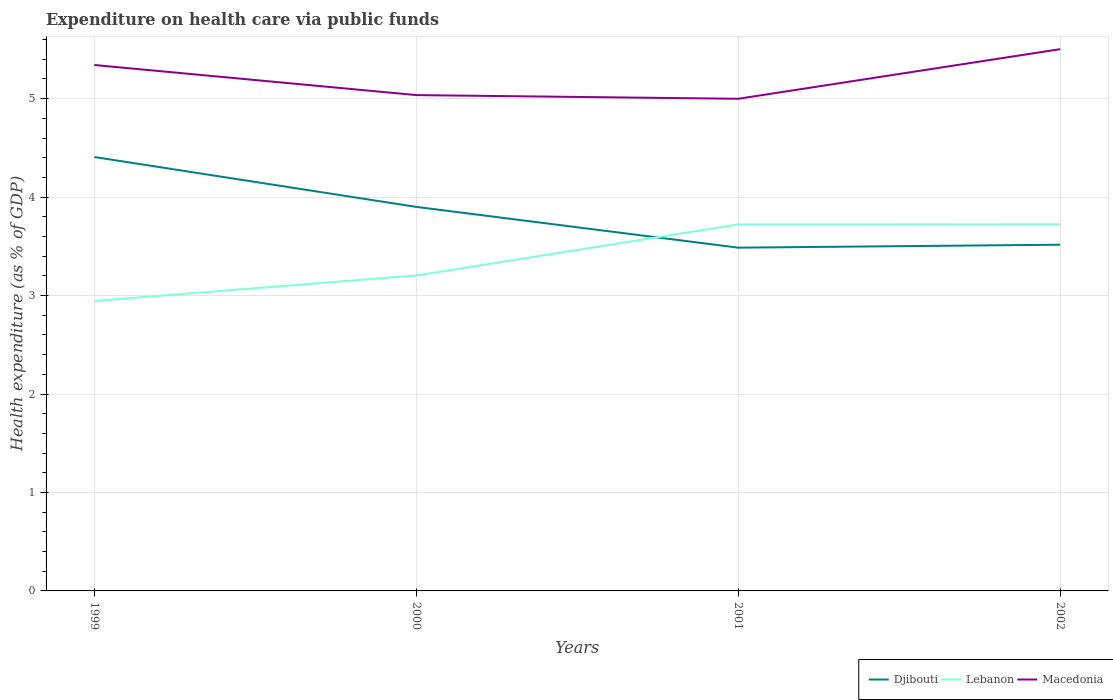How many different coloured lines are there?
Provide a succinct answer. 3. Does the line corresponding to Macedonia intersect with the line corresponding to Djibouti?
Your answer should be compact. No. Is the number of lines equal to the number of legend labels?
Offer a terse response. Yes. Across all years, what is the maximum expenditure made on health care in Macedonia?
Your answer should be very brief. 5. What is the total expenditure made on health care in Macedonia in the graph?
Provide a succinct answer. -0.16. What is the difference between the highest and the second highest expenditure made on health care in Macedonia?
Offer a terse response. 0.5. What is the difference between the highest and the lowest expenditure made on health care in Macedonia?
Your answer should be compact. 2. Is the expenditure made on health care in Lebanon strictly greater than the expenditure made on health care in Djibouti over the years?
Ensure brevity in your answer.  No. How many lines are there?
Make the answer very short. 3. How many years are there in the graph?
Your answer should be very brief. 4. What is the difference between two consecutive major ticks on the Y-axis?
Your answer should be compact. 1. Does the graph contain any zero values?
Offer a terse response. No. How many legend labels are there?
Offer a terse response. 3. What is the title of the graph?
Offer a terse response. Expenditure on health care via public funds. What is the label or title of the X-axis?
Your answer should be very brief. Years. What is the label or title of the Y-axis?
Provide a short and direct response. Health expenditure (as % of GDP). What is the Health expenditure (as % of GDP) in Djibouti in 1999?
Provide a succinct answer. 4.41. What is the Health expenditure (as % of GDP) in Lebanon in 1999?
Make the answer very short. 2.95. What is the Health expenditure (as % of GDP) of Macedonia in 1999?
Make the answer very short. 5.34. What is the Health expenditure (as % of GDP) of Djibouti in 2000?
Offer a very short reply. 3.9. What is the Health expenditure (as % of GDP) in Lebanon in 2000?
Your answer should be compact. 3.2. What is the Health expenditure (as % of GDP) of Macedonia in 2000?
Your response must be concise. 5.04. What is the Health expenditure (as % of GDP) of Djibouti in 2001?
Make the answer very short. 3.49. What is the Health expenditure (as % of GDP) in Lebanon in 2001?
Your response must be concise. 3.72. What is the Health expenditure (as % of GDP) of Macedonia in 2001?
Make the answer very short. 5. What is the Health expenditure (as % of GDP) in Djibouti in 2002?
Offer a very short reply. 3.52. What is the Health expenditure (as % of GDP) in Lebanon in 2002?
Provide a short and direct response. 3.72. What is the Health expenditure (as % of GDP) of Macedonia in 2002?
Provide a succinct answer. 5.5. Across all years, what is the maximum Health expenditure (as % of GDP) of Djibouti?
Make the answer very short. 4.41. Across all years, what is the maximum Health expenditure (as % of GDP) in Lebanon?
Make the answer very short. 3.72. Across all years, what is the maximum Health expenditure (as % of GDP) in Macedonia?
Your answer should be compact. 5.5. Across all years, what is the minimum Health expenditure (as % of GDP) in Djibouti?
Offer a terse response. 3.49. Across all years, what is the minimum Health expenditure (as % of GDP) in Lebanon?
Keep it short and to the point. 2.95. Across all years, what is the minimum Health expenditure (as % of GDP) of Macedonia?
Provide a succinct answer. 5. What is the total Health expenditure (as % of GDP) in Djibouti in the graph?
Keep it short and to the point. 15.31. What is the total Health expenditure (as % of GDP) of Lebanon in the graph?
Your answer should be very brief. 13.6. What is the total Health expenditure (as % of GDP) of Macedonia in the graph?
Keep it short and to the point. 20.88. What is the difference between the Health expenditure (as % of GDP) in Djibouti in 1999 and that in 2000?
Your answer should be very brief. 0.51. What is the difference between the Health expenditure (as % of GDP) in Lebanon in 1999 and that in 2000?
Offer a very short reply. -0.26. What is the difference between the Health expenditure (as % of GDP) of Macedonia in 1999 and that in 2000?
Offer a terse response. 0.31. What is the difference between the Health expenditure (as % of GDP) of Djibouti in 1999 and that in 2001?
Ensure brevity in your answer.  0.92. What is the difference between the Health expenditure (as % of GDP) of Lebanon in 1999 and that in 2001?
Provide a succinct answer. -0.78. What is the difference between the Health expenditure (as % of GDP) in Macedonia in 1999 and that in 2001?
Provide a succinct answer. 0.34. What is the difference between the Health expenditure (as % of GDP) of Djibouti in 1999 and that in 2002?
Provide a short and direct response. 0.89. What is the difference between the Health expenditure (as % of GDP) in Lebanon in 1999 and that in 2002?
Provide a succinct answer. -0.78. What is the difference between the Health expenditure (as % of GDP) in Macedonia in 1999 and that in 2002?
Provide a short and direct response. -0.16. What is the difference between the Health expenditure (as % of GDP) in Djibouti in 2000 and that in 2001?
Keep it short and to the point. 0.41. What is the difference between the Health expenditure (as % of GDP) of Lebanon in 2000 and that in 2001?
Provide a short and direct response. -0.52. What is the difference between the Health expenditure (as % of GDP) in Macedonia in 2000 and that in 2001?
Ensure brevity in your answer.  0.04. What is the difference between the Health expenditure (as % of GDP) of Djibouti in 2000 and that in 2002?
Make the answer very short. 0.38. What is the difference between the Health expenditure (as % of GDP) of Lebanon in 2000 and that in 2002?
Ensure brevity in your answer.  -0.52. What is the difference between the Health expenditure (as % of GDP) in Macedonia in 2000 and that in 2002?
Provide a succinct answer. -0.47. What is the difference between the Health expenditure (as % of GDP) in Djibouti in 2001 and that in 2002?
Your response must be concise. -0.03. What is the difference between the Health expenditure (as % of GDP) of Lebanon in 2001 and that in 2002?
Offer a terse response. -0. What is the difference between the Health expenditure (as % of GDP) of Macedonia in 2001 and that in 2002?
Provide a short and direct response. -0.5. What is the difference between the Health expenditure (as % of GDP) of Djibouti in 1999 and the Health expenditure (as % of GDP) of Lebanon in 2000?
Ensure brevity in your answer.  1.2. What is the difference between the Health expenditure (as % of GDP) of Djibouti in 1999 and the Health expenditure (as % of GDP) of Macedonia in 2000?
Keep it short and to the point. -0.63. What is the difference between the Health expenditure (as % of GDP) of Lebanon in 1999 and the Health expenditure (as % of GDP) of Macedonia in 2000?
Ensure brevity in your answer.  -2.09. What is the difference between the Health expenditure (as % of GDP) of Djibouti in 1999 and the Health expenditure (as % of GDP) of Lebanon in 2001?
Provide a short and direct response. 0.68. What is the difference between the Health expenditure (as % of GDP) of Djibouti in 1999 and the Health expenditure (as % of GDP) of Macedonia in 2001?
Your answer should be very brief. -0.59. What is the difference between the Health expenditure (as % of GDP) of Lebanon in 1999 and the Health expenditure (as % of GDP) of Macedonia in 2001?
Offer a very short reply. -2.05. What is the difference between the Health expenditure (as % of GDP) of Djibouti in 1999 and the Health expenditure (as % of GDP) of Lebanon in 2002?
Keep it short and to the point. 0.68. What is the difference between the Health expenditure (as % of GDP) in Djibouti in 1999 and the Health expenditure (as % of GDP) in Macedonia in 2002?
Provide a succinct answer. -1.1. What is the difference between the Health expenditure (as % of GDP) of Lebanon in 1999 and the Health expenditure (as % of GDP) of Macedonia in 2002?
Ensure brevity in your answer.  -2.56. What is the difference between the Health expenditure (as % of GDP) of Djibouti in 2000 and the Health expenditure (as % of GDP) of Lebanon in 2001?
Give a very brief answer. 0.18. What is the difference between the Health expenditure (as % of GDP) in Djibouti in 2000 and the Health expenditure (as % of GDP) in Macedonia in 2001?
Offer a terse response. -1.1. What is the difference between the Health expenditure (as % of GDP) of Lebanon in 2000 and the Health expenditure (as % of GDP) of Macedonia in 2001?
Your answer should be compact. -1.79. What is the difference between the Health expenditure (as % of GDP) in Djibouti in 2000 and the Health expenditure (as % of GDP) in Lebanon in 2002?
Make the answer very short. 0.18. What is the difference between the Health expenditure (as % of GDP) of Djibouti in 2000 and the Health expenditure (as % of GDP) of Macedonia in 2002?
Your response must be concise. -1.6. What is the difference between the Health expenditure (as % of GDP) in Lebanon in 2000 and the Health expenditure (as % of GDP) in Macedonia in 2002?
Offer a terse response. -2.3. What is the difference between the Health expenditure (as % of GDP) in Djibouti in 2001 and the Health expenditure (as % of GDP) in Lebanon in 2002?
Your response must be concise. -0.24. What is the difference between the Health expenditure (as % of GDP) in Djibouti in 2001 and the Health expenditure (as % of GDP) in Macedonia in 2002?
Your response must be concise. -2.02. What is the difference between the Health expenditure (as % of GDP) in Lebanon in 2001 and the Health expenditure (as % of GDP) in Macedonia in 2002?
Offer a terse response. -1.78. What is the average Health expenditure (as % of GDP) of Djibouti per year?
Make the answer very short. 3.83. What is the average Health expenditure (as % of GDP) in Lebanon per year?
Offer a very short reply. 3.4. What is the average Health expenditure (as % of GDP) in Macedonia per year?
Provide a short and direct response. 5.22. In the year 1999, what is the difference between the Health expenditure (as % of GDP) of Djibouti and Health expenditure (as % of GDP) of Lebanon?
Keep it short and to the point. 1.46. In the year 1999, what is the difference between the Health expenditure (as % of GDP) in Djibouti and Health expenditure (as % of GDP) in Macedonia?
Provide a succinct answer. -0.93. In the year 1999, what is the difference between the Health expenditure (as % of GDP) in Lebanon and Health expenditure (as % of GDP) in Macedonia?
Provide a succinct answer. -2.4. In the year 2000, what is the difference between the Health expenditure (as % of GDP) in Djibouti and Health expenditure (as % of GDP) in Lebanon?
Offer a very short reply. 0.7. In the year 2000, what is the difference between the Health expenditure (as % of GDP) of Djibouti and Health expenditure (as % of GDP) of Macedonia?
Your answer should be compact. -1.14. In the year 2000, what is the difference between the Health expenditure (as % of GDP) of Lebanon and Health expenditure (as % of GDP) of Macedonia?
Offer a very short reply. -1.83. In the year 2001, what is the difference between the Health expenditure (as % of GDP) of Djibouti and Health expenditure (as % of GDP) of Lebanon?
Offer a terse response. -0.24. In the year 2001, what is the difference between the Health expenditure (as % of GDP) in Djibouti and Health expenditure (as % of GDP) in Macedonia?
Your answer should be compact. -1.51. In the year 2001, what is the difference between the Health expenditure (as % of GDP) in Lebanon and Health expenditure (as % of GDP) in Macedonia?
Your answer should be very brief. -1.28. In the year 2002, what is the difference between the Health expenditure (as % of GDP) in Djibouti and Health expenditure (as % of GDP) in Lebanon?
Your answer should be compact. -0.21. In the year 2002, what is the difference between the Health expenditure (as % of GDP) of Djibouti and Health expenditure (as % of GDP) of Macedonia?
Offer a very short reply. -1.99. In the year 2002, what is the difference between the Health expenditure (as % of GDP) in Lebanon and Health expenditure (as % of GDP) in Macedonia?
Keep it short and to the point. -1.78. What is the ratio of the Health expenditure (as % of GDP) in Djibouti in 1999 to that in 2000?
Offer a very short reply. 1.13. What is the ratio of the Health expenditure (as % of GDP) in Lebanon in 1999 to that in 2000?
Make the answer very short. 0.92. What is the ratio of the Health expenditure (as % of GDP) of Macedonia in 1999 to that in 2000?
Provide a short and direct response. 1.06. What is the ratio of the Health expenditure (as % of GDP) of Djibouti in 1999 to that in 2001?
Give a very brief answer. 1.26. What is the ratio of the Health expenditure (as % of GDP) in Lebanon in 1999 to that in 2001?
Your answer should be compact. 0.79. What is the ratio of the Health expenditure (as % of GDP) of Macedonia in 1999 to that in 2001?
Your response must be concise. 1.07. What is the ratio of the Health expenditure (as % of GDP) of Djibouti in 1999 to that in 2002?
Your answer should be very brief. 1.25. What is the ratio of the Health expenditure (as % of GDP) of Lebanon in 1999 to that in 2002?
Make the answer very short. 0.79. What is the ratio of the Health expenditure (as % of GDP) in Macedonia in 1999 to that in 2002?
Give a very brief answer. 0.97. What is the ratio of the Health expenditure (as % of GDP) of Djibouti in 2000 to that in 2001?
Offer a very short reply. 1.12. What is the ratio of the Health expenditure (as % of GDP) of Lebanon in 2000 to that in 2001?
Your answer should be compact. 0.86. What is the ratio of the Health expenditure (as % of GDP) of Macedonia in 2000 to that in 2001?
Give a very brief answer. 1.01. What is the ratio of the Health expenditure (as % of GDP) in Djibouti in 2000 to that in 2002?
Offer a terse response. 1.11. What is the ratio of the Health expenditure (as % of GDP) of Lebanon in 2000 to that in 2002?
Your answer should be very brief. 0.86. What is the ratio of the Health expenditure (as % of GDP) of Macedonia in 2000 to that in 2002?
Provide a short and direct response. 0.92. What is the ratio of the Health expenditure (as % of GDP) of Djibouti in 2001 to that in 2002?
Your response must be concise. 0.99. What is the ratio of the Health expenditure (as % of GDP) of Macedonia in 2001 to that in 2002?
Ensure brevity in your answer.  0.91. What is the difference between the highest and the second highest Health expenditure (as % of GDP) in Djibouti?
Your answer should be compact. 0.51. What is the difference between the highest and the second highest Health expenditure (as % of GDP) in Lebanon?
Give a very brief answer. 0. What is the difference between the highest and the second highest Health expenditure (as % of GDP) of Macedonia?
Your response must be concise. 0.16. What is the difference between the highest and the lowest Health expenditure (as % of GDP) in Djibouti?
Ensure brevity in your answer.  0.92. What is the difference between the highest and the lowest Health expenditure (as % of GDP) of Lebanon?
Ensure brevity in your answer.  0.78. What is the difference between the highest and the lowest Health expenditure (as % of GDP) in Macedonia?
Keep it short and to the point. 0.5. 